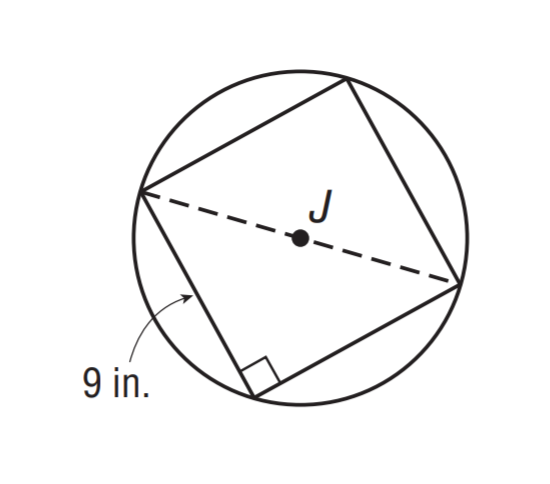Question: A square with side length of 9 inches is inscribed in \odot J. Find the exact circumference of \odot J.
Choices:
A. 8 \sqrt 2 \pi
B. 9 \sqrt 2 \pi
C. 12 \sqrt 2 \pi
D. 15 \sqrt 2 \pi
Answer with the letter. Answer: B 